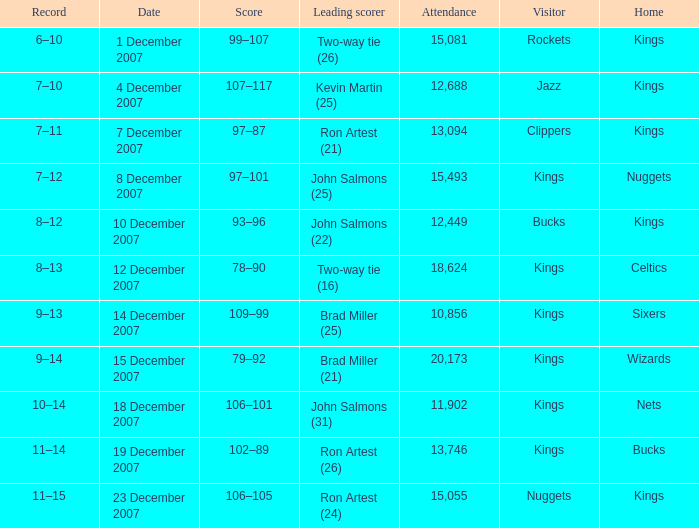What was the record of the game where the Rockets were the visiting team? 6–10. Can you give me this table as a dict? {'header': ['Record', 'Date', 'Score', 'Leading scorer', 'Attendance', 'Visitor', 'Home'], 'rows': [['6–10', '1 December 2007', '99–107', 'Two-way tie (26)', '15,081', 'Rockets', 'Kings'], ['7–10', '4 December 2007', '107–117', 'Kevin Martin (25)', '12,688', 'Jazz', 'Kings'], ['7–11', '7 December 2007', '97–87', 'Ron Artest (21)', '13,094', 'Clippers', 'Kings'], ['7–12', '8 December 2007', '97–101', 'John Salmons (25)', '15,493', 'Kings', 'Nuggets'], ['8–12', '10 December 2007', '93–96', 'John Salmons (22)', '12,449', 'Bucks', 'Kings'], ['8–13', '12 December 2007', '78–90', 'Two-way tie (16)', '18,624', 'Kings', 'Celtics'], ['9–13', '14 December 2007', '109–99', 'Brad Miller (25)', '10,856', 'Kings', 'Sixers'], ['9–14', '15 December 2007', '79–92', 'Brad Miller (21)', '20,173', 'Kings', 'Wizards'], ['10–14', '18 December 2007', '106–101', 'John Salmons (31)', '11,902', 'Kings', 'Nets'], ['11–14', '19 December 2007', '102–89', 'Ron Artest (26)', '13,746', 'Kings', 'Bucks'], ['11–15', '23 December 2007', '106–105', 'Ron Artest (24)', '15,055', 'Nuggets', 'Kings']]} 